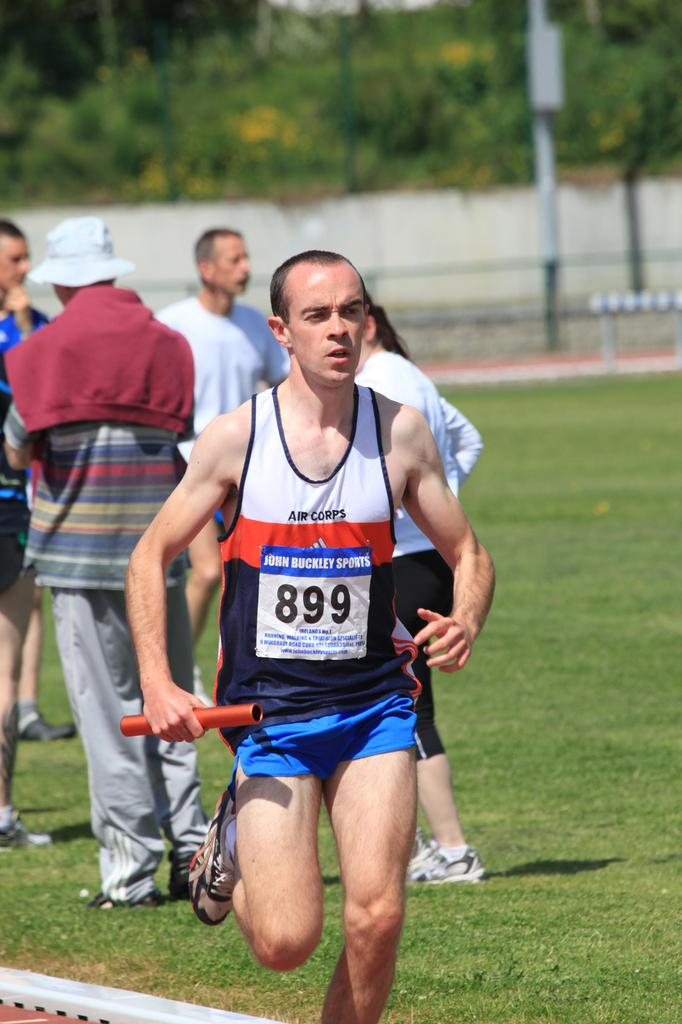<image>
Summarize the visual content of the image. The runner with the baton is wearing the number 899. 